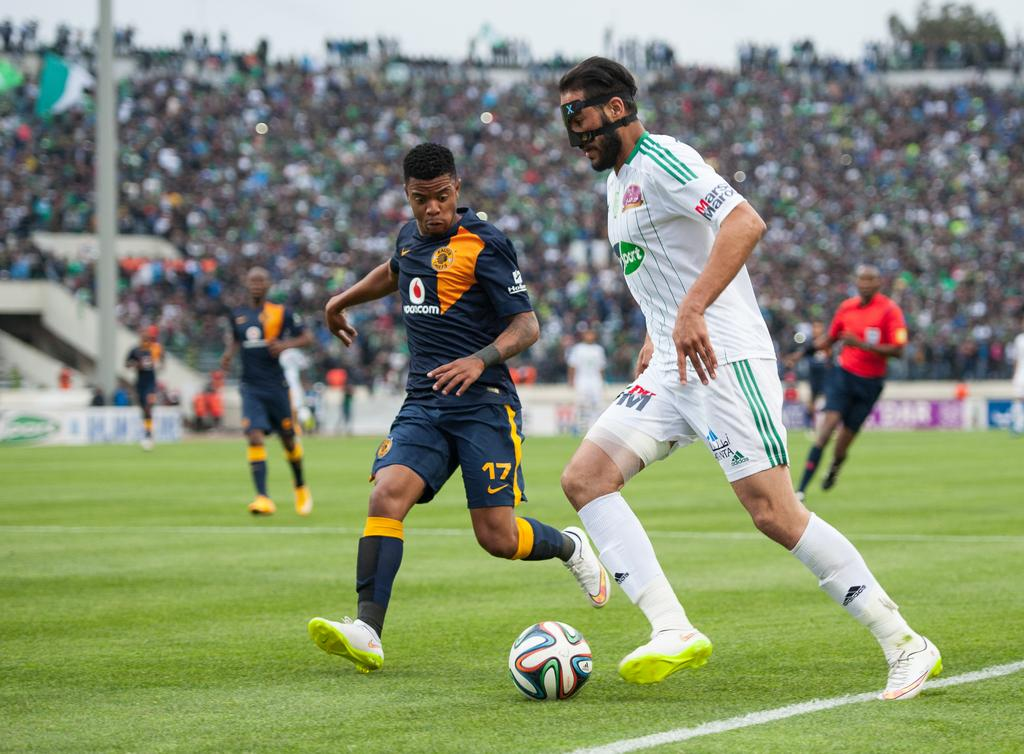What are the people in the image doing? The people in the image are playing on the ground. What object can be seen in the image that is commonly used in games? There is a ball visible in the image. What type of surface are the people playing on? There is grass in the image, which is the surface they are playing on. What structures can be seen in the background of the image? There are hoardings and a pole visible in the background of the image. What can be seen in the background of the image that indicates a gathering of people? There is a crowd in the background of the image. What can be seen in the background of the image that represents a specific group or event? There are flags in the background of the image. What is visible in the background of the image that indicates the weather or time of day? The sky is visible in the background of the image. What type of guitar can be seen in the image? There is no guitar present in the image. 